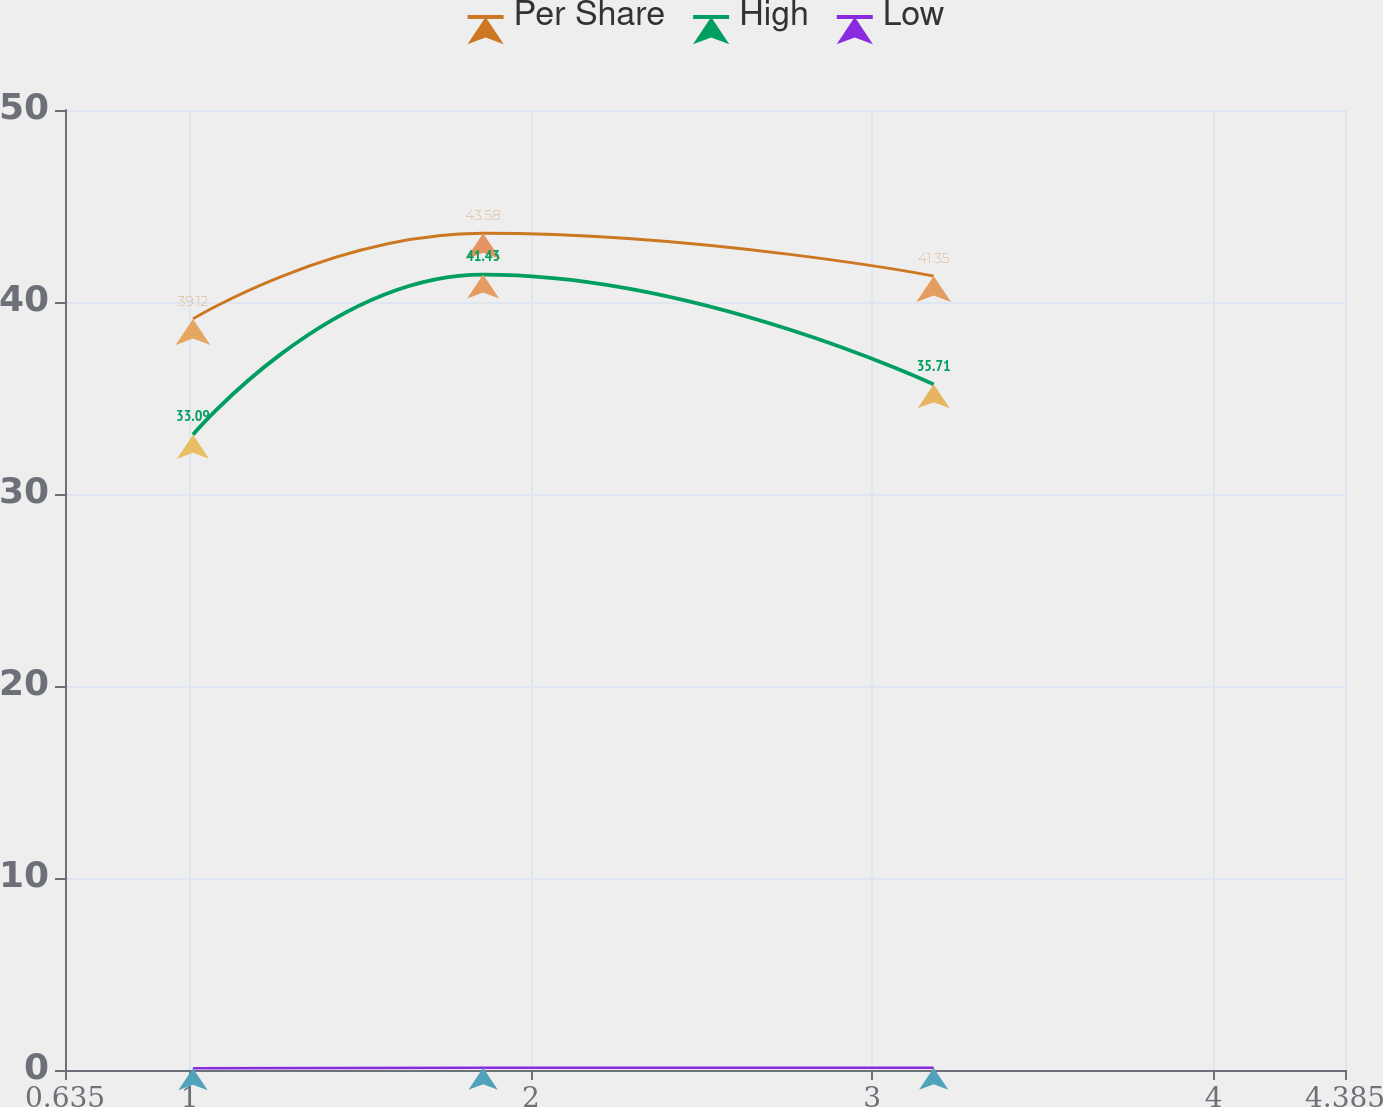Convert chart. <chart><loc_0><loc_0><loc_500><loc_500><line_chart><ecel><fcel>Per Share<fcel>High<fcel>Low<nl><fcel>1.01<fcel>39.12<fcel>33.09<fcel>0.09<nl><fcel>1.86<fcel>43.58<fcel>41.43<fcel>0.12<nl><fcel>3.18<fcel>41.35<fcel>35.71<fcel>0.12<nl><fcel>4.76<fcel>61.45<fcel>54.44<fcel>0.13<nl></chart> 